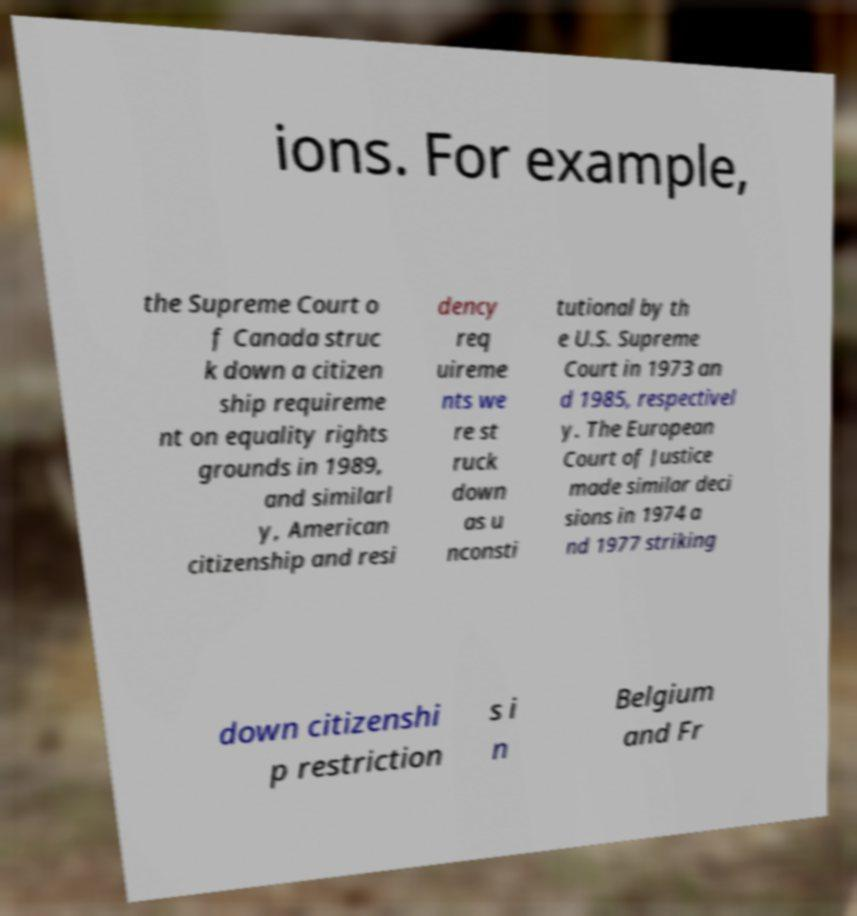Please read and relay the text visible in this image. What does it say? ions. For example, the Supreme Court o f Canada struc k down a citizen ship requireme nt on equality rights grounds in 1989, and similarl y, American citizenship and resi dency req uireme nts we re st ruck down as u nconsti tutional by th e U.S. Supreme Court in 1973 an d 1985, respectivel y. The European Court of Justice made similar deci sions in 1974 a nd 1977 striking down citizenshi p restriction s i n Belgium and Fr 